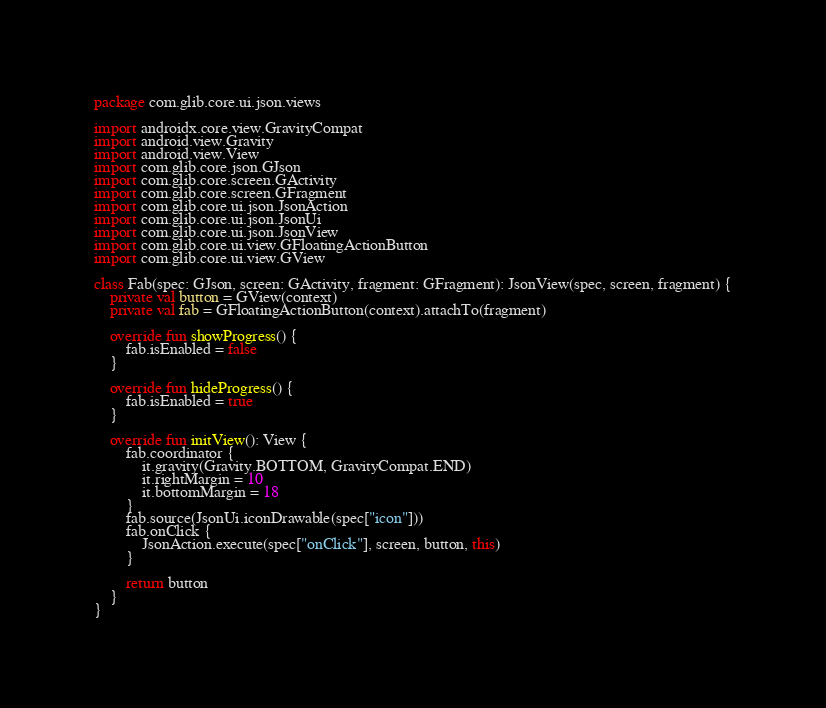<code> <loc_0><loc_0><loc_500><loc_500><_Kotlin_>package com.glib.core.ui.json.views

import androidx.core.view.GravityCompat
import android.view.Gravity
import android.view.View
import com.glib.core.json.GJson
import com.glib.core.screen.GActivity
import com.glib.core.screen.GFragment
import com.glib.core.ui.json.JsonAction
import com.glib.core.ui.json.JsonUi
import com.glib.core.ui.json.JsonView
import com.glib.core.ui.view.GFloatingActionButton
import com.glib.core.ui.view.GView

class Fab(spec: GJson, screen: GActivity, fragment: GFragment): JsonView(spec, screen, fragment) {
    private val button = GView(context)
    private val fab = GFloatingActionButton(context).attachTo(fragment)

    override fun showProgress() {
        fab.isEnabled = false
    }

    override fun hideProgress() {
        fab.isEnabled = true
    }

    override fun initView(): View {
        fab.coordinator {
            it.gravity(Gravity.BOTTOM, GravityCompat.END)
            it.rightMargin = 10
            it.bottomMargin = 18
        }
        fab.source(JsonUi.iconDrawable(spec["icon"]))
        fab.onClick {
            JsonAction.execute(spec["onClick"], screen, button, this)
        }

        return button
    }
}
</code> 